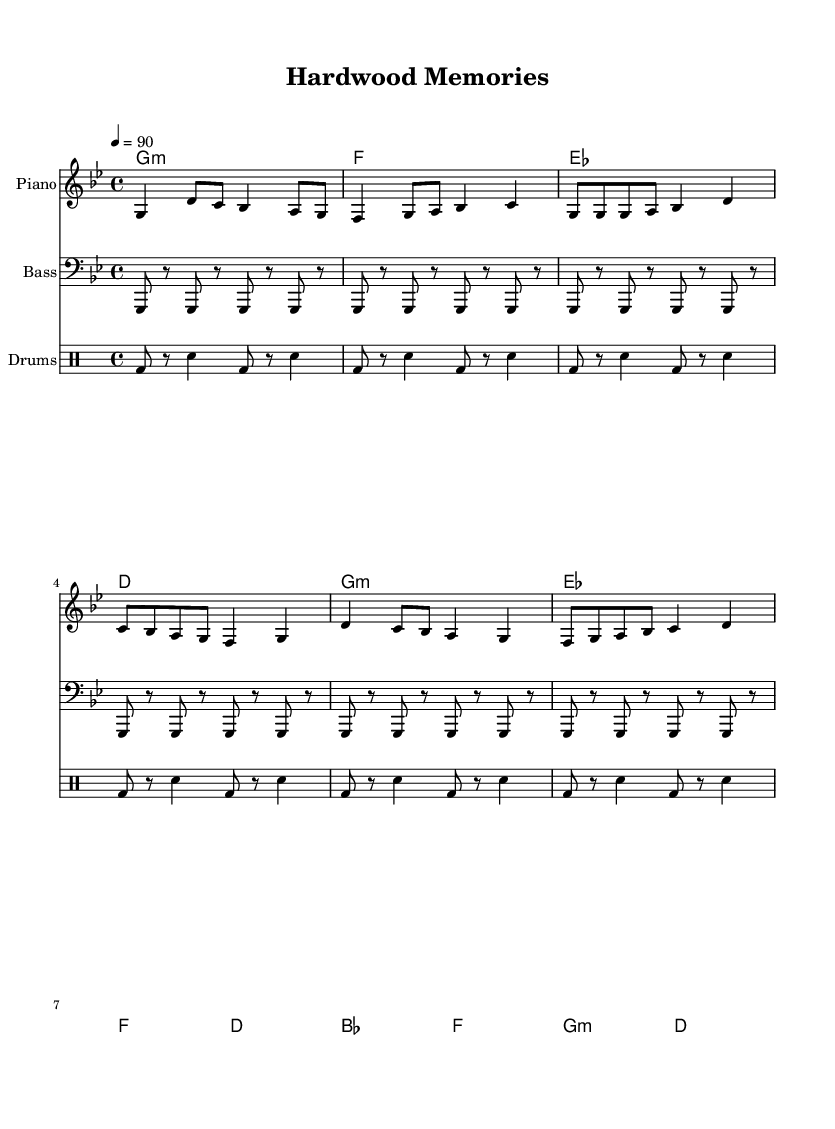What is the key signature of this music? The key signature is G minor, which has two flats (B♭ and E♭). This can be identified at the beginning of the staff, indicated by the presence of these flat symbols.
Answer: G minor What is the time signature of this music? The time signature is 4/4, which is indicated at the beginning of the score, telling us that there are four beats per measure and the quarter note gets one beat.
Answer: 4/4 What is the tempo marking for this piece? The tempo marking is 90 beats per minute; it is specified with the text "4 = 90" under the tempo indication, indicating the metronomic speed.
Answer: 90 How many measures are in the chorus section? The chorus consists of four measures, which can be counted by identifying the groupings of the melody and harmonies labeled under the chorus section.
Answer: 4 What instrument represents the melody in this score? The melody is played on the piano, as indicated by the label of the staff that carries the melodic line.
Answer: Piano What type of chord progression is used in the verse? The chord progression in the verse alternates between minor and major chords, identified by looking at the chord symbols corresponding to the melody notes in the verse.
Answer: Minor and major What genre does this music represent? The genre represented is Hip Hop, indicated by the style and the use of drum patterns typical in hip hop music, along with the nostalgic vibes intertwined with the basketball theme.
Answer: Hip Hop 